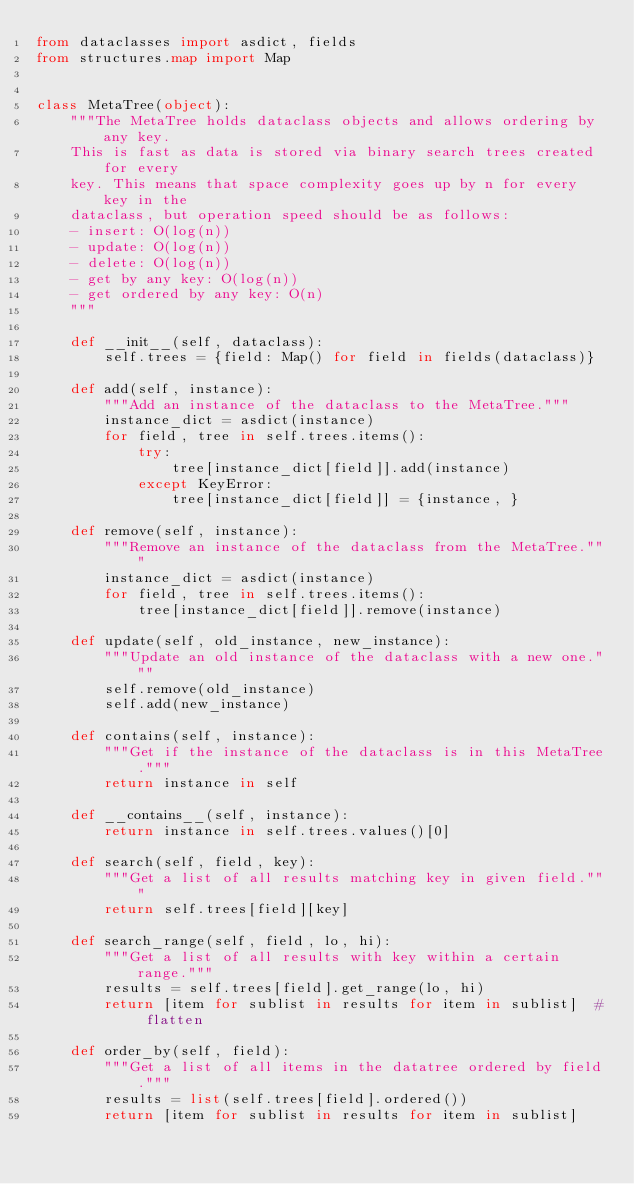Convert code to text. <code><loc_0><loc_0><loc_500><loc_500><_Python_>from dataclasses import asdict, fields
from structures.map import Map


class MetaTree(object):
    """The MetaTree holds dataclass objects and allows ordering by any key.
    This is fast as data is stored via binary search trees created for every
    key. This means that space complexity goes up by n for every key in the
    dataclass, but operation speed should be as follows:
    - insert: O(log(n))
    - update: O(log(n))
    - delete: O(log(n))
    - get by any key: O(log(n))
    - get ordered by any key: O(n)
    """

    def __init__(self, dataclass):
        self.trees = {field: Map() for field in fields(dataclass)}

    def add(self, instance):
        """Add an instance of the dataclass to the MetaTree."""
        instance_dict = asdict(instance)
        for field, tree in self.trees.items():
            try:
                tree[instance_dict[field]].add(instance)
            except KeyError:
                tree[instance_dict[field]] = {instance, }

    def remove(self, instance):
        """Remove an instance of the dataclass from the MetaTree."""
        instance_dict = asdict(instance)
        for field, tree in self.trees.items():
            tree[instance_dict[field]].remove(instance)

    def update(self, old_instance, new_instance):
        """Update an old instance of the dataclass with a new one."""
        self.remove(old_instance)
        self.add(new_instance)

    def contains(self, instance):
        """Get if the instance of the dataclass is in this MetaTree."""
        return instance in self

    def __contains__(self, instance):
        return instance in self.trees.values()[0]

    def search(self, field, key):
        """Get a list of all results matching key in given field."""
        return self.trees[field][key]

    def search_range(self, field, lo, hi):
        """Get a list of all results with key within a certain range."""
        results = self.trees[field].get_range(lo, hi)
        return [item for sublist in results for item in sublist]  # flatten

    def order_by(self, field):
        """Get a list of all items in the datatree ordered by field."""
        results = list(self.trees[field].ordered())
        return [item for sublist in results for item in sublist]
</code> 